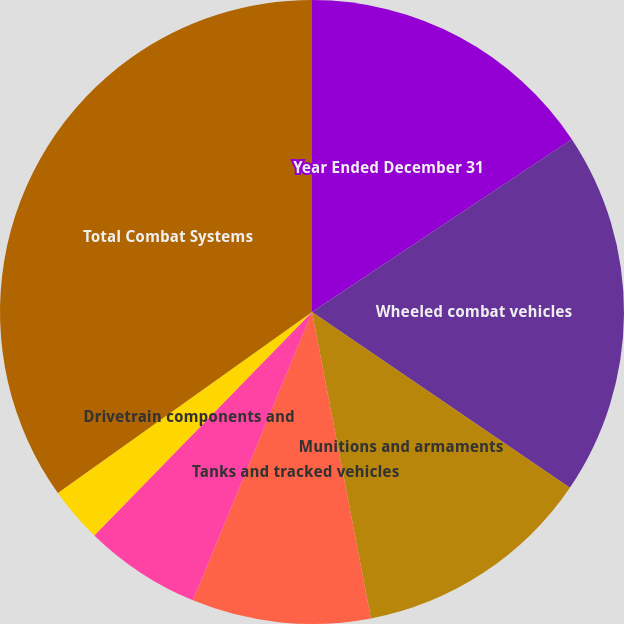Convert chart to OTSL. <chart><loc_0><loc_0><loc_500><loc_500><pie_chart><fcel>Year Ended December 31<fcel>Wheeled combat vehicles<fcel>Munitions and armaments<fcel>Tanks and tracked vehicles<fcel>Engineering and development<fcel>Drivetrain components and<fcel>Total Combat Systems<nl><fcel>15.66%<fcel>18.86%<fcel>12.46%<fcel>9.26%<fcel>6.06%<fcel>2.86%<fcel>34.85%<nl></chart> 